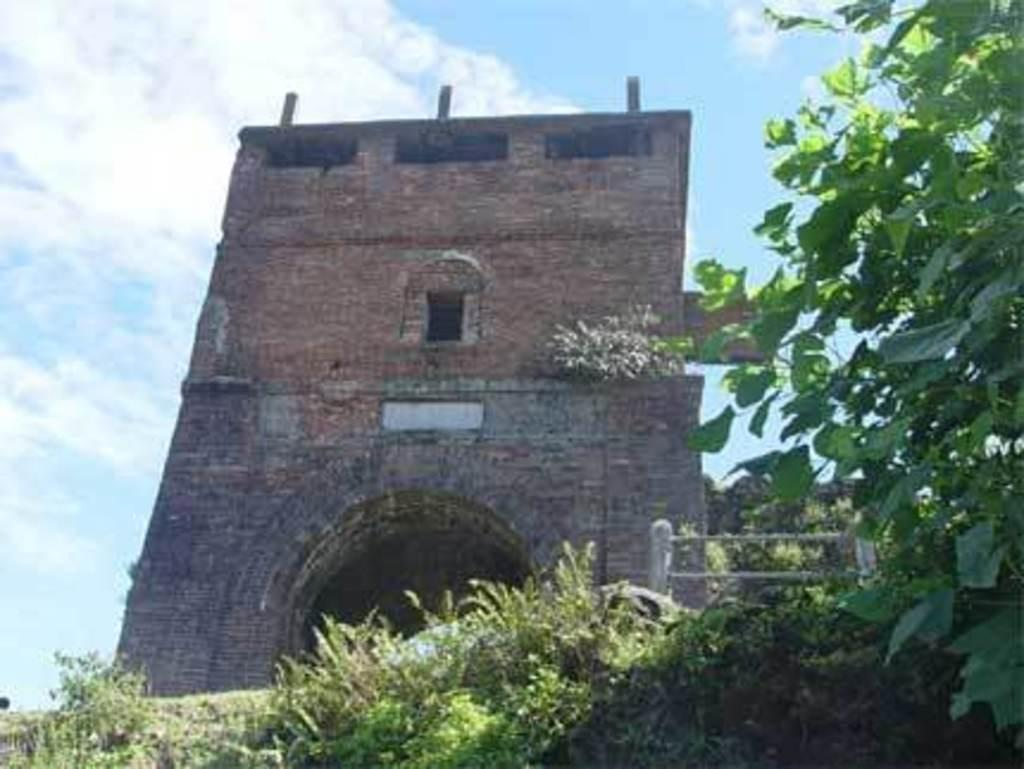What type of structure is present in the image? There is a building in the image. What can be seen in front of the building? There are trees and plants in front of the building. What is visible in the background of the image? The sky is visible in the background of the image. What type of soup is being served in the building in the image? There is no soup or indication of food in the image; it only features a building, trees, plants, and the sky. 